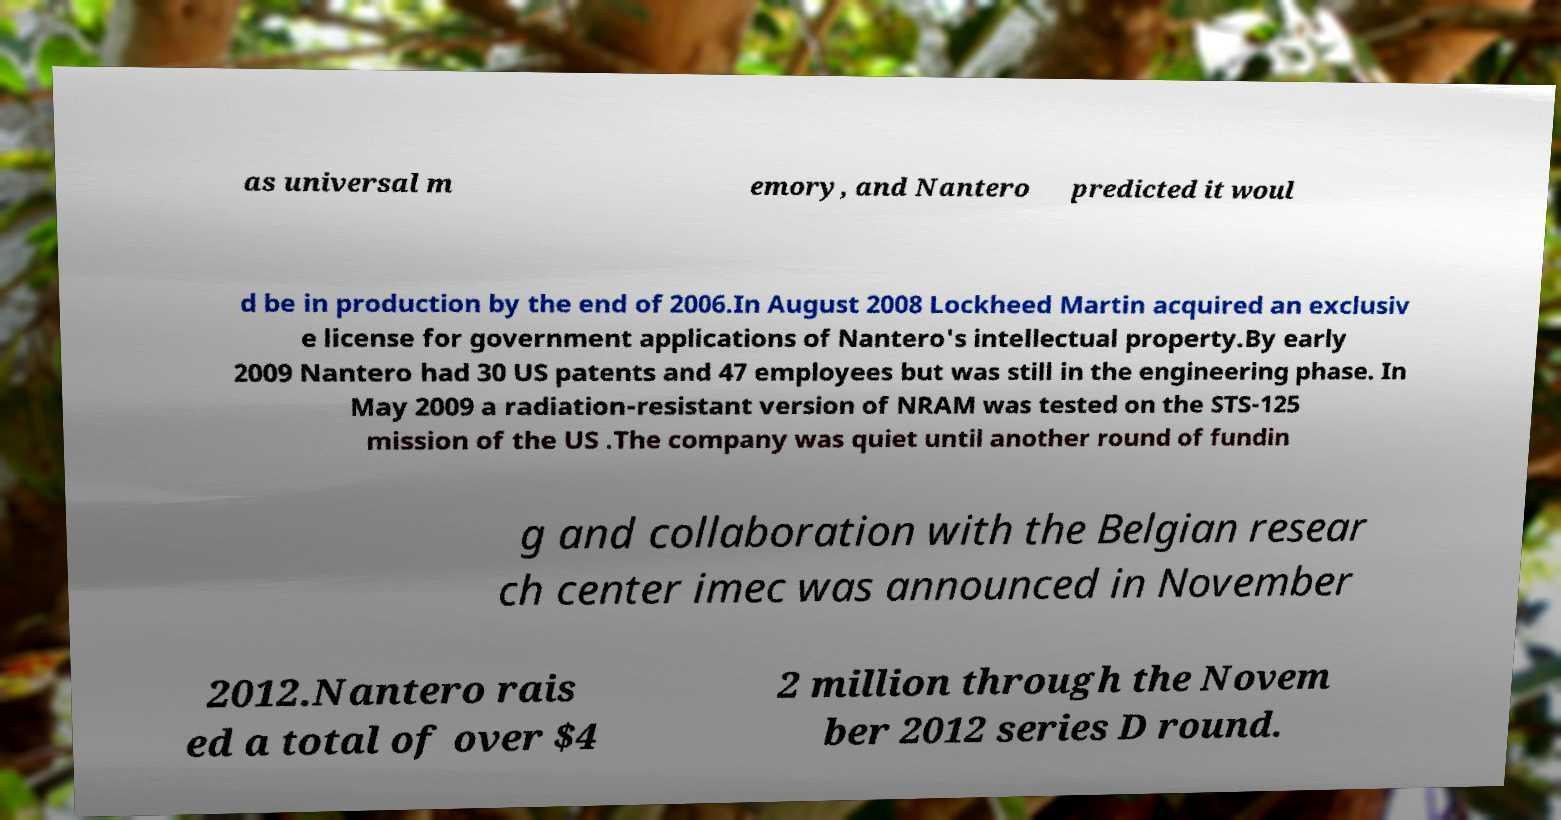There's text embedded in this image that I need extracted. Can you transcribe it verbatim? as universal m emory, and Nantero predicted it woul d be in production by the end of 2006.In August 2008 Lockheed Martin acquired an exclusiv e license for government applications of Nantero's intellectual property.By early 2009 Nantero had 30 US patents and 47 employees but was still in the engineering phase. In May 2009 a radiation-resistant version of NRAM was tested on the STS-125 mission of the US .The company was quiet until another round of fundin g and collaboration with the Belgian resear ch center imec was announced in November 2012.Nantero rais ed a total of over $4 2 million through the Novem ber 2012 series D round. 